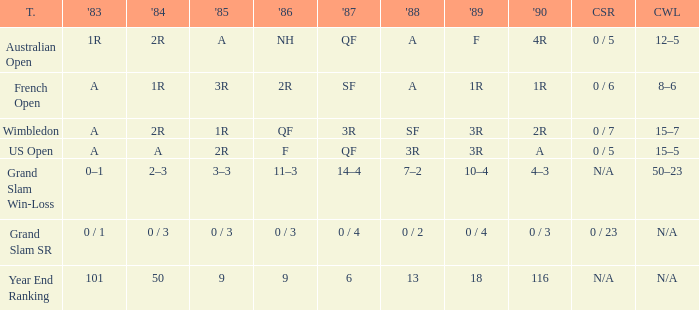With a 1986 of NH and a career SR of 0 / 5 what is the results in 1985? A. 